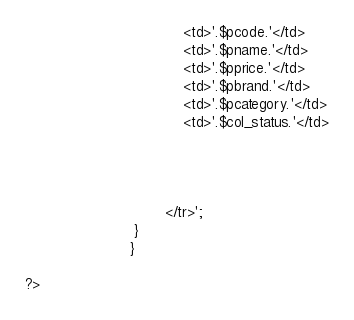<code> <loc_0><loc_0><loc_500><loc_500><_PHP_>									<td>'.$pcode.'</td>
									<td>'.$pname.'</td>
									<td>'.$pprice.'</td>
									<td>'.$pbrand.'</td>
									<td>'.$pcategory.'</td>
									<td>'.$col_status.'</td>



									
								</tr>';
						 }
						}
							 					 
?></code> 